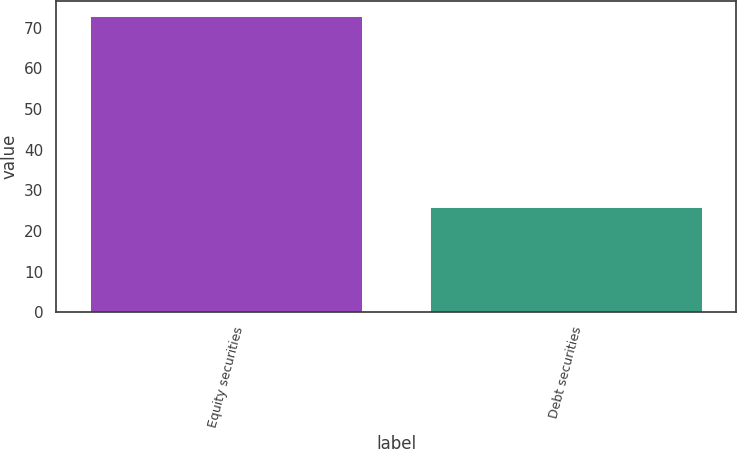Convert chart. <chart><loc_0><loc_0><loc_500><loc_500><bar_chart><fcel>Equity securities<fcel>Debt securities<nl><fcel>73<fcel>26<nl></chart> 